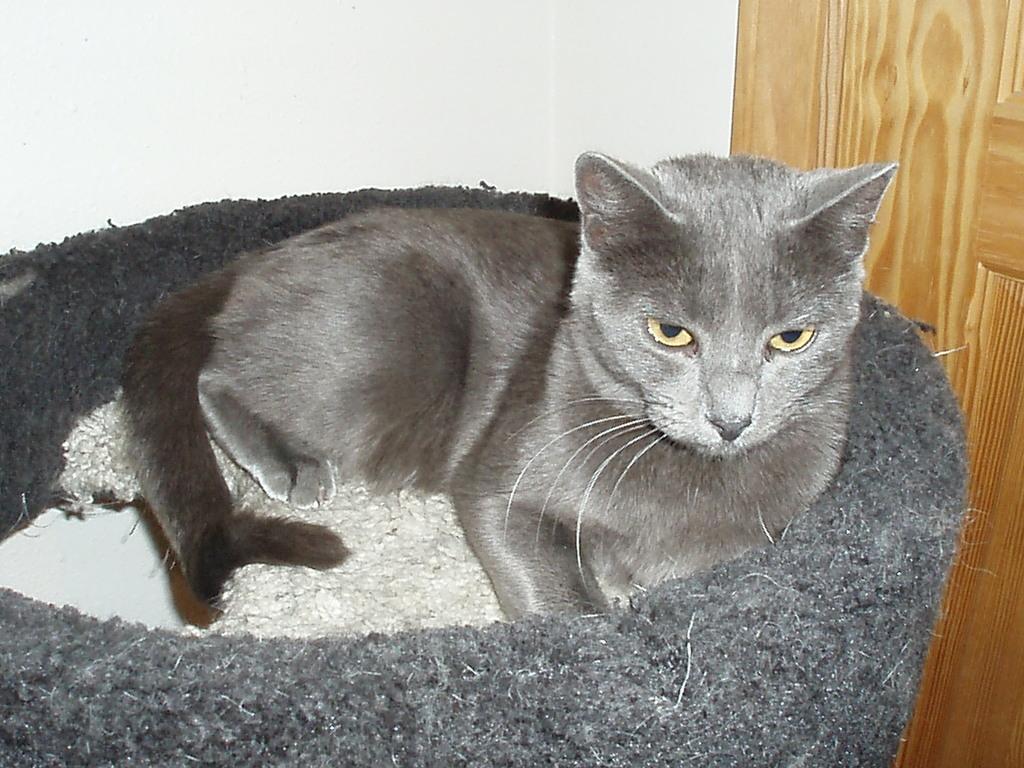In one or two sentences, can you explain what this image depicts? In this image I can see the cat which is in ash and grey color. It is on the white and grey color object. In the background I can see the white and brown color wall. 